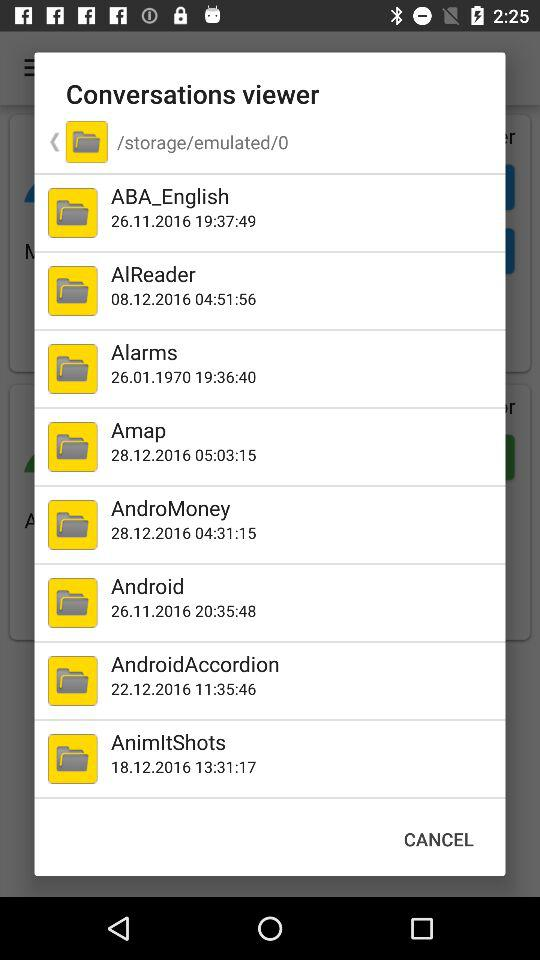What's the mentioned date of saving the "Alarms" file? The mentioned date of saving the "Alarms" file is January 26, 1970. 